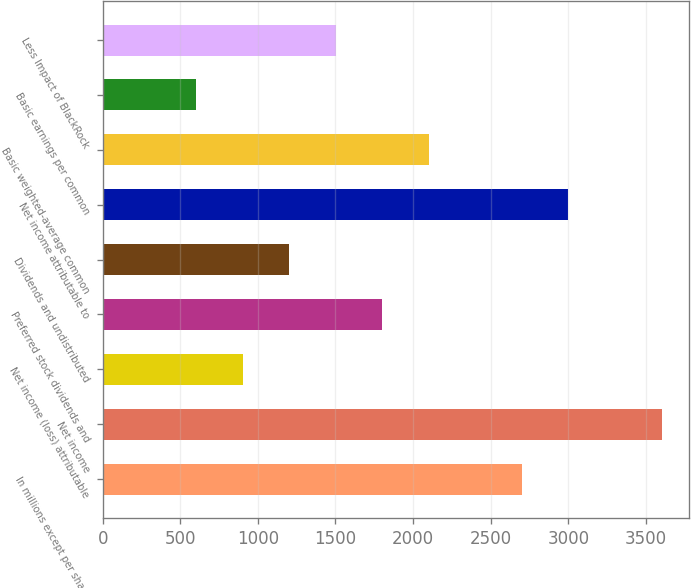Convert chart to OTSL. <chart><loc_0><loc_0><loc_500><loc_500><bar_chart><fcel>In millions except per share<fcel>Net income<fcel>Net income (loss) attributable<fcel>Preferred stock dividends and<fcel>Dividends and undistributed<fcel>Net income attributable to<fcel>Basic weighted-average common<fcel>Basic earnings per common<fcel>Less Impact of BlackRock<nl><fcel>2701.2<fcel>3600.6<fcel>902.4<fcel>1801.8<fcel>1202.2<fcel>3001<fcel>2101.6<fcel>602.6<fcel>1502<nl></chart> 